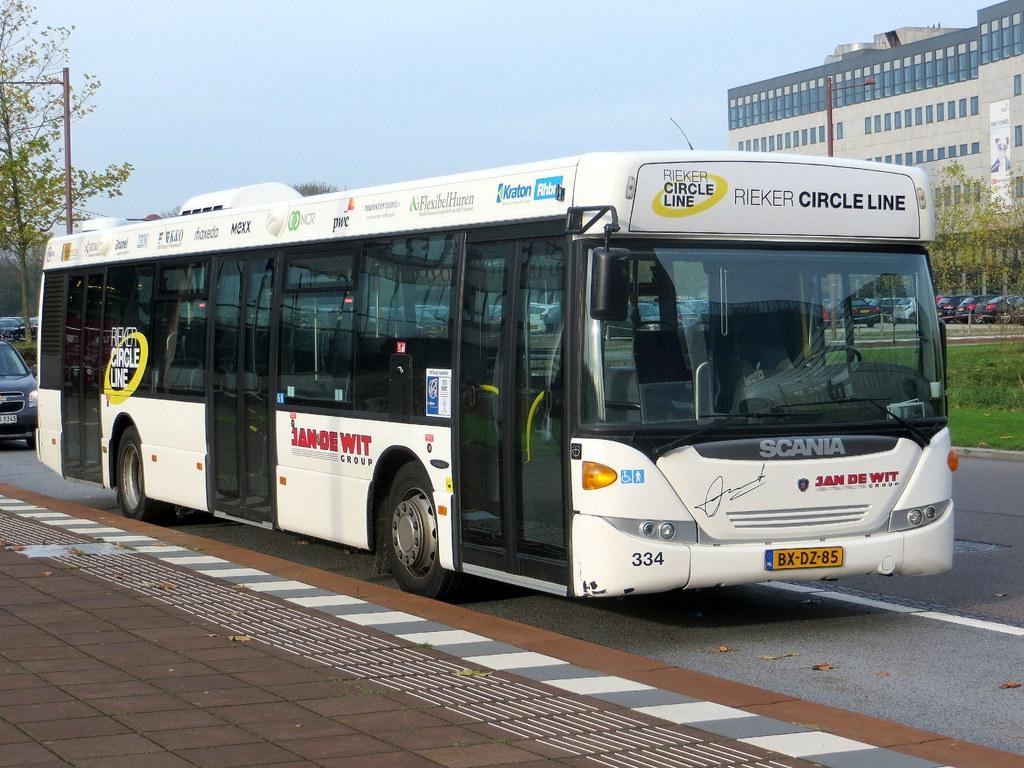<image>
Relay a brief, clear account of the picture shown. A Rieker circle line bus with Jan De Wit group written on the side of it. 